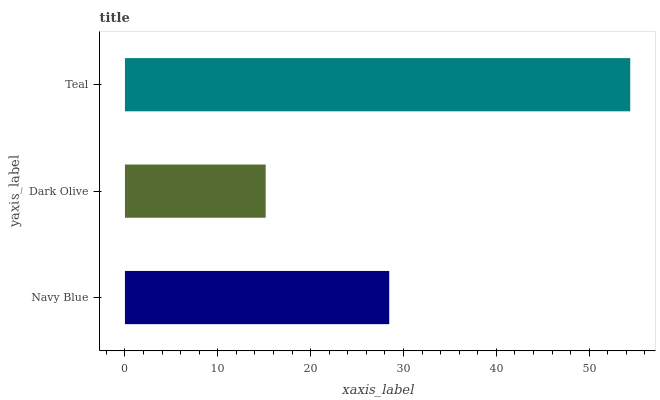Is Dark Olive the minimum?
Answer yes or no. Yes. Is Teal the maximum?
Answer yes or no. Yes. Is Teal the minimum?
Answer yes or no. No. Is Dark Olive the maximum?
Answer yes or no. No. Is Teal greater than Dark Olive?
Answer yes or no. Yes. Is Dark Olive less than Teal?
Answer yes or no. Yes. Is Dark Olive greater than Teal?
Answer yes or no. No. Is Teal less than Dark Olive?
Answer yes or no. No. Is Navy Blue the high median?
Answer yes or no. Yes. Is Navy Blue the low median?
Answer yes or no. Yes. Is Teal the high median?
Answer yes or no. No. Is Teal the low median?
Answer yes or no. No. 